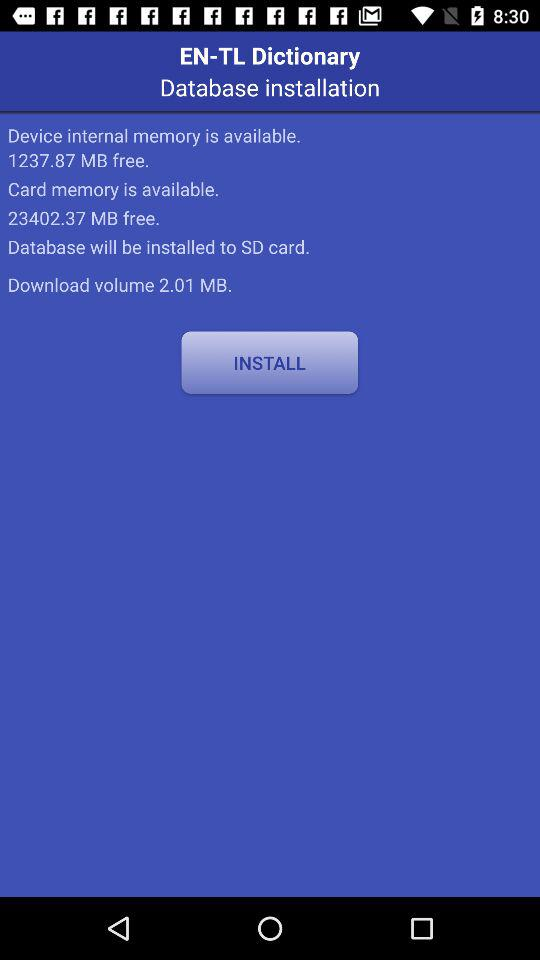What is the available free space in card memory? The available free space in card memory is 23402.37 MB. 